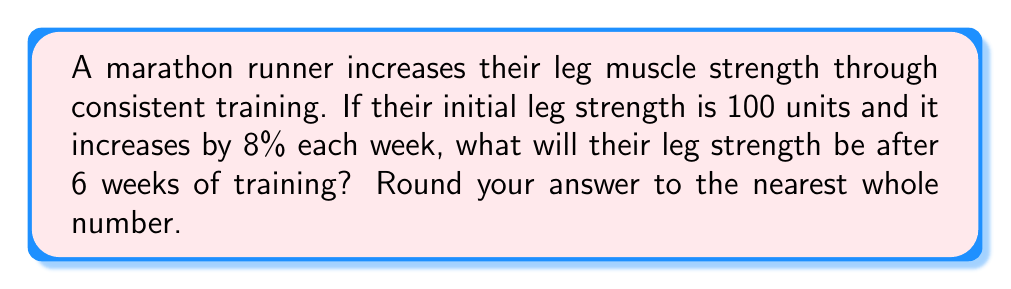Solve this math problem. Let's approach this step-by-step:

1) The initial strength is 100 units.
2) The weekly increase is 8% or 0.08 in decimal form.
3) We need to calculate this for 6 weeks.

This scenario represents exponential growth, which can be modeled by the equation:

$$ A = P(1 + r)^t $$

Where:
$A$ = final amount
$P$ = initial amount (principal)
$r$ = growth rate (as a decimal)
$t$ = time period

Plugging in our values:

$$ A = 100(1 + 0.08)^6 $$

Now, let's calculate:

$$ A = 100(1.08)^6 $$
$$ A = 100(1.5869) $$
$$ A = 158.69 $$

Rounding to the nearest whole number:

$$ A ≈ 159 $$
Answer: 159 units 